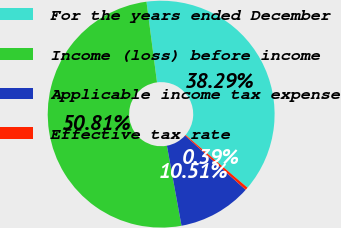Convert chart to OTSL. <chart><loc_0><loc_0><loc_500><loc_500><pie_chart><fcel>For the years ended December<fcel>Income (loss) before income<fcel>Applicable income tax expense<fcel>Effective tax rate<nl><fcel>38.29%<fcel>50.8%<fcel>10.51%<fcel>0.39%<nl></chart> 